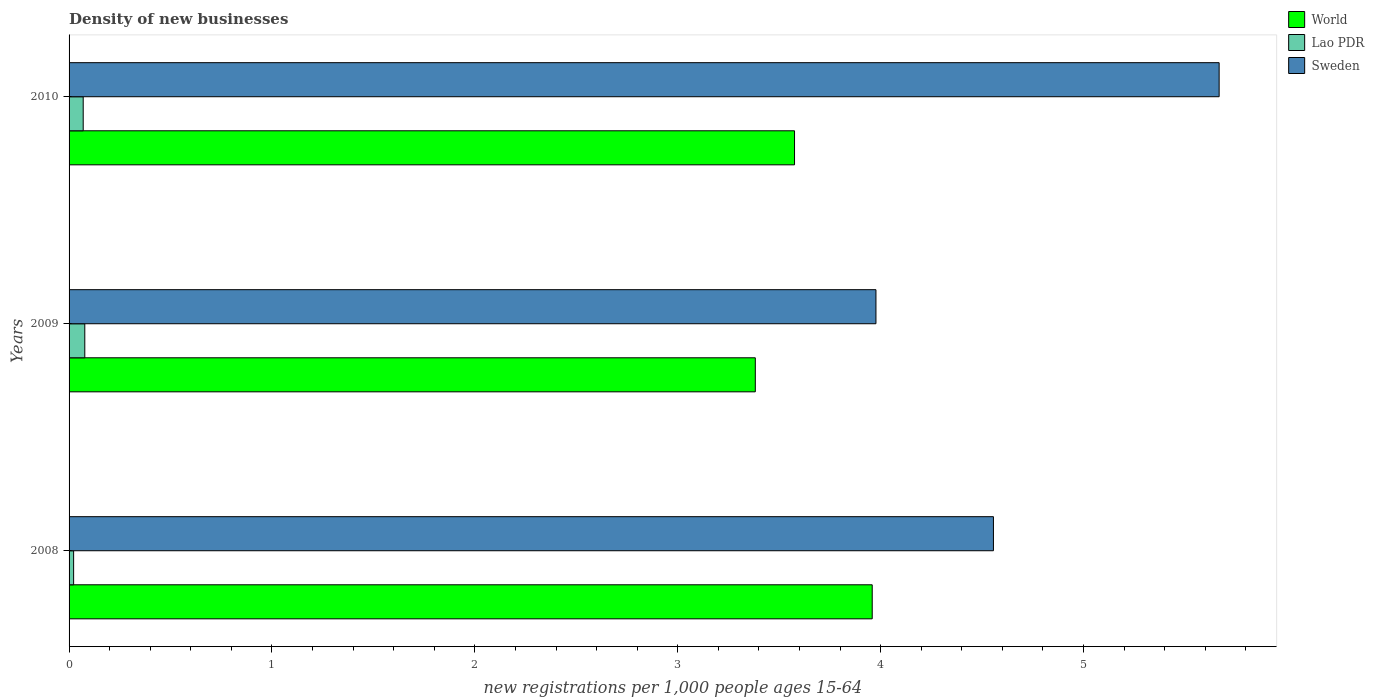Are the number of bars on each tick of the Y-axis equal?
Provide a succinct answer. Yes. What is the label of the 2nd group of bars from the top?
Your answer should be compact. 2009. In how many cases, is the number of bars for a given year not equal to the number of legend labels?
Keep it short and to the point. 0. What is the number of new registrations in Sweden in 2008?
Provide a short and direct response. 4.56. Across all years, what is the maximum number of new registrations in Sweden?
Offer a terse response. 5.67. Across all years, what is the minimum number of new registrations in Sweden?
Ensure brevity in your answer.  3.98. In which year was the number of new registrations in Sweden minimum?
Your response must be concise. 2009. What is the total number of new registrations in World in the graph?
Your answer should be compact. 10.92. What is the difference between the number of new registrations in Sweden in 2009 and that in 2010?
Provide a succinct answer. -1.69. What is the difference between the number of new registrations in Lao PDR in 2010 and the number of new registrations in World in 2009?
Offer a very short reply. -3.31. What is the average number of new registrations in World per year?
Your answer should be very brief. 3.64. In the year 2008, what is the difference between the number of new registrations in Sweden and number of new registrations in Lao PDR?
Your response must be concise. 4.53. In how many years, is the number of new registrations in Sweden greater than 5.2 ?
Keep it short and to the point. 1. What is the ratio of the number of new registrations in World in 2008 to that in 2009?
Give a very brief answer. 1.17. Is the number of new registrations in Sweden in 2008 less than that in 2010?
Ensure brevity in your answer.  Yes. Is the difference between the number of new registrations in Sweden in 2008 and 2009 greater than the difference between the number of new registrations in Lao PDR in 2008 and 2009?
Ensure brevity in your answer.  Yes. What is the difference between the highest and the second highest number of new registrations in World?
Offer a terse response. 0.38. What is the difference between the highest and the lowest number of new registrations in Sweden?
Offer a very short reply. 1.69. What does the 1st bar from the top in 2008 represents?
Keep it short and to the point. Sweden. What does the 2nd bar from the bottom in 2009 represents?
Offer a terse response. Lao PDR. Is it the case that in every year, the sum of the number of new registrations in Lao PDR and number of new registrations in World is greater than the number of new registrations in Sweden?
Ensure brevity in your answer.  No. Are all the bars in the graph horizontal?
Provide a succinct answer. Yes. How many legend labels are there?
Your response must be concise. 3. How are the legend labels stacked?
Give a very brief answer. Vertical. What is the title of the graph?
Your answer should be compact. Density of new businesses. Does "Samoa" appear as one of the legend labels in the graph?
Your answer should be compact. No. What is the label or title of the X-axis?
Your response must be concise. New registrations per 1,0 people ages 15-64. What is the label or title of the Y-axis?
Provide a succinct answer. Years. What is the new registrations per 1,000 people ages 15-64 of World in 2008?
Provide a short and direct response. 3.96. What is the new registrations per 1,000 people ages 15-64 of Lao PDR in 2008?
Offer a very short reply. 0.02. What is the new registrations per 1,000 people ages 15-64 of Sweden in 2008?
Offer a very short reply. 4.56. What is the new registrations per 1,000 people ages 15-64 in World in 2009?
Ensure brevity in your answer.  3.38. What is the new registrations per 1,000 people ages 15-64 of Lao PDR in 2009?
Your answer should be very brief. 0.08. What is the new registrations per 1,000 people ages 15-64 of Sweden in 2009?
Make the answer very short. 3.98. What is the new registrations per 1,000 people ages 15-64 of World in 2010?
Give a very brief answer. 3.58. What is the new registrations per 1,000 people ages 15-64 of Lao PDR in 2010?
Give a very brief answer. 0.07. What is the new registrations per 1,000 people ages 15-64 in Sweden in 2010?
Offer a terse response. 5.67. Across all years, what is the maximum new registrations per 1,000 people ages 15-64 in World?
Give a very brief answer. 3.96. Across all years, what is the maximum new registrations per 1,000 people ages 15-64 of Lao PDR?
Your response must be concise. 0.08. Across all years, what is the maximum new registrations per 1,000 people ages 15-64 in Sweden?
Ensure brevity in your answer.  5.67. Across all years, what is the minimum new registrations per 1,000 people ages 15-64 in World?
Your response must be concise. 3.38. Across all years, what is the minimum new registrations per 1,000 people ages 15-64 in Lao PDR?
Offer a very short reply. 0.02. Across all years, what is the minimum new registrations per 1,000 people ages 15-64 of Sweden?
Your answer should be very brief. 3.98. What is the total new registrations per 1,000 people ages 15-64 of World in the graph?
Provide a short and direct response. 10.92. What is the total new registrations per 1,000 people ages 15-64 of Lao PDR in the graph?
Provide a succinct answer. 0.17. What is the total new registrations per 1,000 people ages 15-64 in Sweden in the graph?
Offer a terse response. 14.2. What is the difference between the new registrations per 1,000 people ages 15-64 of World in 2008 and that in 2009?
Ensure brevity in your answer.  0.58. What is the difference between the new registrations per 1,000 people ages 15-64 in Lao PDR in 2008 and that in 2009?
Offer a very short reply. -0.06. What is the difference between the new registrations per 1,000 people ages 15-64 of Sweden in 2008 and that in 2009?
Make the answer very short. 0.58. What is the difference between the new registrations per 1,000 people ages 15-64 in World in 2008 and that in 2010?
Offer a very short reply. 0.38. What is the difference between the new registrations per 1,000 people ages 15-64 of Lao PDR in 2008 and that in 2010?
Keep it short and to the point. -0.05. What is the difference between the new registrations per 1,000 people ages 15-64 of Sweden in 2008 and that in 2010?
Your answer should be very brief. -1.11. What is the difference between the new registrations per 1,000 people ages 15-64 of World in 2009 and that in 2010?
Your answer should be very brief. -0.19. What is the difference between the new registrations per 1,000 people ages 15-64 of Lao PDR in 2009 and that in 2010?
Make the answer very short. 0.01. What is the difference between the new registrations per 1,000 people ages 15-64 of Sweden in 2009 and that in 2010?
Ensure brevity in your answer.  -1.69. What is the difference between the new registrations per 1,000 people ages 15-64 of World in 2008 and the new registrations per 1,000 people ages 15-64 of Lao PDR in 2009?
Ensure brevity in your answer.  3.88. What is the difference between the new registrations per 1,000 people ages 15-64 of World in 2008 and the new registrations per 1,000 people ages 15-64 of Sweden in 2009?
Provide a short and direct response. -0.02. What is the difference between the new registrations per 1,000 people ages 15-64 in Lao PDR in 2008 and the new registrations per 1,000 people ages 15-64 in Sweden in 2009?
Your answer should be compact. -3.95. What is the difference between the new registrations per 1,000 people ages 15-64 of World in 2008 and the new registrations per 1,000 people ages 15-64 of Lao PDR in 2010?
Make the answer very short. 3.89. What is the difference between the new registrations per 1,000 people ages 15-64 in World in 2008 and the new registrations per 1,000 people ages 15-64 in Sweden in 2010?
Offer a terse response. -1.71. What is the difference between the new registrations per 1,000 people ages 15-64 of Lao PDR in 2008 and the new registrations per 1,000 people ages 15-64 of Sweden in 2010?
Make the answer very short. -5.65. What is the difference between the new registrations per 1,000 people ages 15-64 of World in 2009 and the new registrations per 1,000 people ages 15-64 of Lao PDR in 2010?
Your answer should be very brief. 3.31. What is the difference between the new registrations per 1,000 people ages 15-64 of World in 2009 and the new registrations per 1,000 people ages 15-64 of Sweden in 2010?
Your answer should be compact. -2.29. What is the difference between the new registrations per 1,000 people ages 15-64 of Lao PDR in 2009 and the new registrations per 1,000 people ages 15-64 of Sweden in 2010?
Offer a very short reply. -5.59. What is the average new registrations per 1,000 people ages 15-64 in World per year?
Provide a short and direct response. 3.64. What is the average new registrations per 1,000 people ages 15-64 of Lao PDR per year?
Your response must be concise. 0.06. What is the average new registrations per 1,000 people ages 15-64 in Sweden per year?
Offer a terse response. 4.73. In the year 2008, what is the difference between the new registrations per 1,000 people ages 15-64 of World and new registrations per 1,000 people ages 15-64 of Lao PDR?
Provide a short and direct response. 3.94. In the year 2008, what is the difference between the new registrations per 1,000 people ages 15-64 of World and new registrations per 1,000 people ages 15-64 of Sweden?
Your answer should be compact. -0.6. In the year 2008, what is the difference between the new registrations per 1,000 people ages 15-64 in Lao PDR and new registrations per 1,000 people ages 15-64 in Sweden?
Offer a very short reply. -4.53. In the year 2009, what is the difference between the new registrations per 1,000 people ages 15-64 of World and new registrations per 1,000 people ages 15-64 of Lao PDR?
Your response must be concise. 3.3. In the year 2009, what is the difference between the new registrations per 1,000 people ages 15-64 in World and new registrations per 1,000 people ages 15-64 in Sweden?
Your answer should be very brief. -0.59. In the year 2009, what is the difference between the new registrations per 1,000 people ages 15-64 in Lao PDR and new registrations per 1,000 people ages 15-64 in Sweden?
Offer a terse response. -3.9. In the year 2010, what is the difference between the new registrations per 1,000 people ages 15-64 of World and new registrations per 1,000 people ages 15-64 of Lao PDR?
Offer a very short reply. 3.51. In the year 2010, what is the difference between the new registrations per 1,000 people ages 15-64 of World and new registrations per 1,000 people ages 15-64 of Sweden?
Your answer should be compact. -2.09. In the year 2010, what is the difference between the new registrations per 1,000 people ages 15-64 in Lao PDR and new registrations per 1,000 people ages 15-64 in Sweden?
Your answer should be very brief. -5.6. What is the ratio of the new registrations per 1,000 people ages 15-64 of World in 2008 to that in 2009?
Give a very brief answer. 1.17. What is the ratio of the new registrations per 1,000 people ages 15-64 of Lao PDR in 2008 to that in 2009?
Keep it short and to the point. 0.29. What is the ratio of the new registrations per 1,000 people ages 15-64 in Sweden in 2008 to that in 2009?
Make the answer very short. 1.15. What is the ratio of the new registrations per 1,000 people ages 15-64 in World in 2008 to that in 2010?
Make the answer very short. 1.11. What is the ratio of the new registrations per 1,000 people ages 15-64 in Lao PDR in 2008 to that in 2010?
Give a very brief answer. 0.32. What is the ratio of the new registrations per 1,000 people ages 15-64 in Sweden in 2008 to that in 2010?
Offer a very short reply. 0.8. What is the ratio of the new registrations per 1,000 people ages 15-64 in World in 2009 to that in 2010?
Provide a short and direct response. 0.95. What is the ratio of the new registrations per 1,000 people ages 15-64 in Lao PDR in 2009 to that in 2010?
Offer a terse response. 1.11. What is the ratio of the new registrations per 1,000 people ages 15-64 of Sweden in 2009 to that in 2010?
Offer a very short reply. 0.7. What is the difference between the highest and the second highest new registrations per 1,000 people ages 15-64 in World?
Offer a very short reply. 0.38. What is the difference between the highest and the second highest new registrations per 1,000 people ages 15-64 of Lao PDR?
Offer a very short reply. 0.01. What is the difference between the highest and the second highest new registrations per 1,000 people ages 15-64 in Sweden?
Provide a succinct answer. 1.11. What is the difference between the highest and the lowest new registrations per 1,000 people ages 15-64 of World?
Ensure brevity in your answer.  0.58. What is the difference between the highest and the lowest new registrations per 1,000 people ages 15-64 in Lao PDR?
Provide a succinct answer. 0.06. What is the difference between the highest and the lowest new registrations per 1,000 people ages 15-64 of Sweden?
Give a very brief answer. 1.69. 